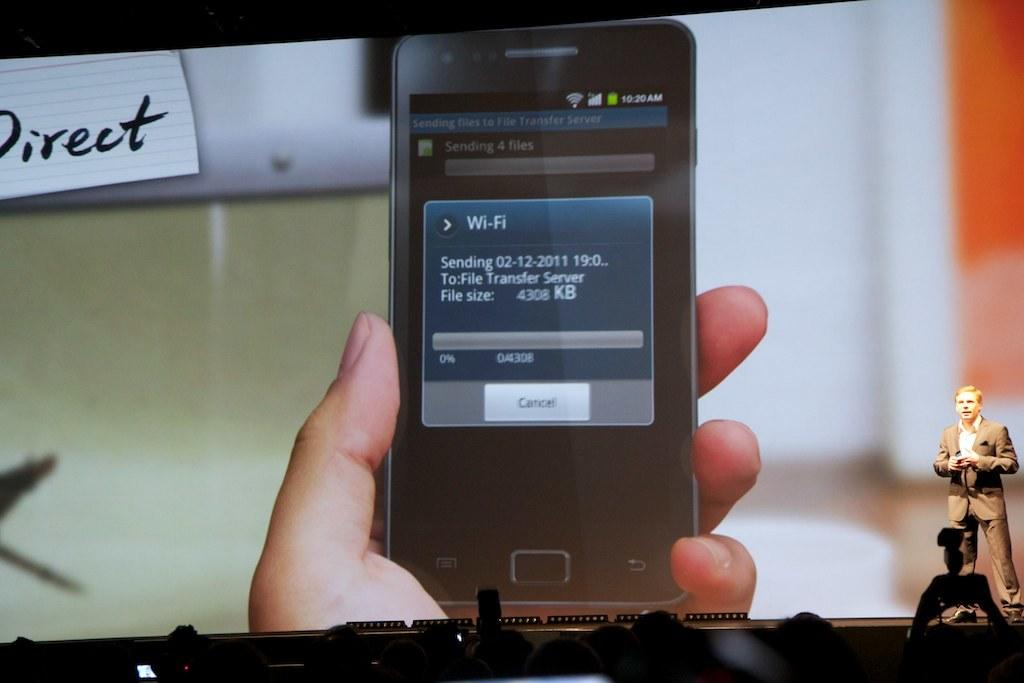Provide a one-sentence caption for the provided image. A phone screen is open to a Wi-Fi screen, which is sending a file. 